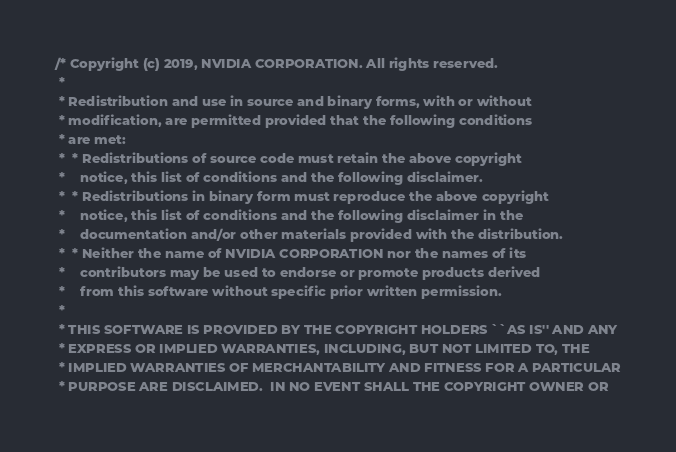Convert code to text. <code><loc_0><loc_0><loc_500><loc_500><_Cuda_>/* Copyright (c) 2019, NVIDIA CORPORATION. All rights reserved.
 *
 * Redistribution and use in source and binary forms, with or without
 * modification, are permitted provided that the following conditions
 * are met:
 *  * Redistributions of source code must retain the above copyright
 *    notice, this list of conditions and the following disclaimer.
 *  * Redistributions in binary form must reproduce the above copyright
 *    notice, this list of conditions and the following disclaimer in the
 *    documentation and/or other materials provided with the distribution.
 *  * Neither the name of NVIDIA CORPORATION nor the names of its
 *    contributors may be used to endorse or promote products derived
 *    from this software without specific prior written permission.
 *
 * THIS SOFTWARE IS PROVIDED BY THE COPYRIGHT HOLDERS ``AS IS'' AND ANY
 * EXPRESS OR IMPLIED WARRANTIES, INCLUDING, BUT NOT LIMITED TO, THE
 * IMPLIED WARRANTIES OF MERCHANTABILITY AND FITNESS FOR A PARTICULAR
 * PURPOSE ARE DISCLAIMED.  IN NO EVENT SHALL THE COPYRIGHT OWNER OR</code> 